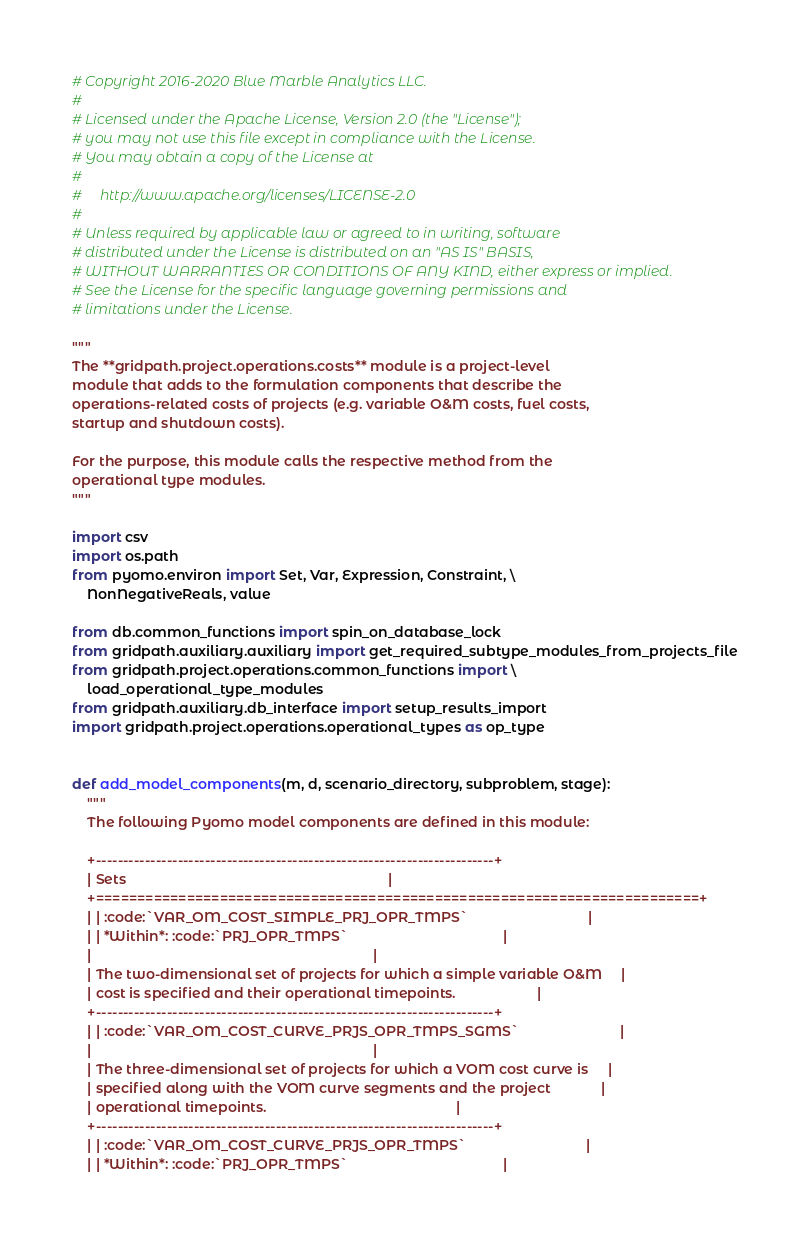<code> <loc_0><loc_0><loc_500><loc_500><_Python_># Copyright 2016-2020 Blue Marble Analytics LLC.
#
# Licensed under the Apache License, Version 2.0 (the "License");
# you may not use this file except in compliance with the License.
# You may obtain a copy of the License at
#
#     http://www.apache.org/licenses/LICENSE-2.0
#
# Unless required by applicable law or agreed to in writing, software
# distributed under the License is distributed on an "AS IS" BASIS,
# WITHOUT WARRANTIES OR CONDITIONS OF ANY KIND, either express or implied.
# See the License for the specific language governing permissions and
# limitations under the License.

"""
The **gridpath.project.operations.costs** module is a project-level
module that adds to the formulation components that describe the
operations-related costs of projects (e.g. variable O&M costs, fuel costs,
startup and shutdown costs).

For the purpose, this module calls the respective method from the
operational type modules.
"""

import csv
import os.path
from pyomo.environ import Set, Var, Expression, Constraint, \
    NonNegativeReals, value

from db.common_functions import spin_on_database_lock
from gridpath.auxiliary.auxiliary import get_required_subtype_modules_from_projects_file
from gridpath.project.operations.common_functions import \
    load_operational_type_modules
from gridpath.auxiliary.db_interface import setup_results_import
import gridpath.project.operations.operational_types as op_type


def add_model_components(m, d, scenario_directory, subproblem, stage):
    """
    The following Pyomo model components are defined in this module:

    +-------------------------------------------------------------------------+
    | Sets                                                                    |
    +=========================================================================+
    | | :code:`VAR_OM_COST_SIMPLE_PRJ_OPR_TMPS`                               |
    | | *Within*: :code:`PRJ_OPR_TMPS`                                        |
    |                                                                         |
    | The two-dimensional set of projects for which a simple variable O&M     |
    | cost is specified and their operational timepoints.                     |
    +-------------------------------------------------------------------------+
    | | :code:`VAR_OM_COST_CURVE_PRJS_OPR_TMPS_SGMS`                          |
    |                                                                         |
    | The three-dimensional set of projects for which a VOM cost curve is     |
    | specified along with the VOM curve segments and the project             |
    | operational timepoints.                                                 |
    +-------------------------------------------------------------------------+
    | | :code:`VAR_OM_COST_CURVE_PRJS_OPR_TMPS`                               |
    | | *Within*: :code:`PRJ_OPR_TMPS`                                        |</code> 